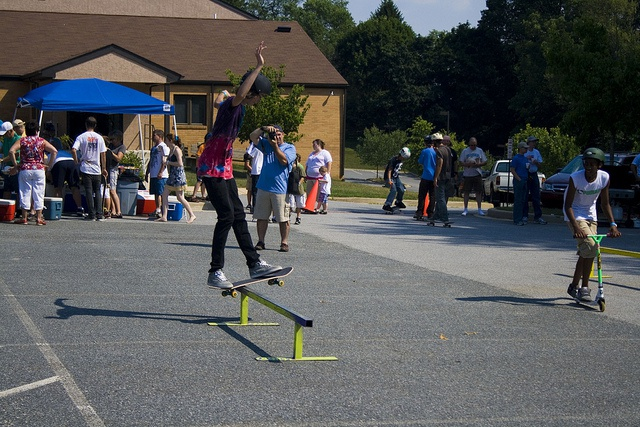Describe the objects in this image and their specific colors. I can see people in gray, black, navy, and darkgray tones, people in gray, black, maroon, and navy tones, people in gray, black, and darkblue tones, people in gray, black, navy, and darkgray tones, and people in gray, black, and lightgray tones in this image. 